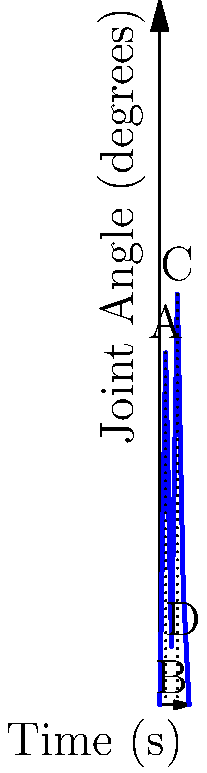In the graph above, which represents knee joint angle measurements during a single gait cycle, what is the range of motion (ROM) of the knee joint in degrees? Provide your answer based on the empirical data presented in the graph. To determine the range of motion (ROM) of the knee joint during this gait cycle, we need to follow these steps:

1. Identify the maximum knee flexion angle:
   From the graph, we can see that the maximum flexion occurs at point C, which is approximately 70°.

2. Identify the minimum knee flexion angle (maximum extension):
   The minimum flexion (maximum extension) occurs at point B, which is approximately 10°.

3. Calculate the range of motion:
   ROM = Maximum flexion - Minimum flexion
   ROM = 70° - 10° = 60°

This approach is based on the empirical evidence provided in the graph, which aligns with the persona's belief in basing conclusions on observable data. The ROM represents the total angular displacement of the knee joint throughout the gait cycle, from its most extended position to its most flexed position.

It's important to note that this analysis assumes the graph represents a typical gait cycle and that the measurement technique was reliable and valid, which would be critical considerations for a psychology professor emphasizing empirical evidence.
Answer: 60° 